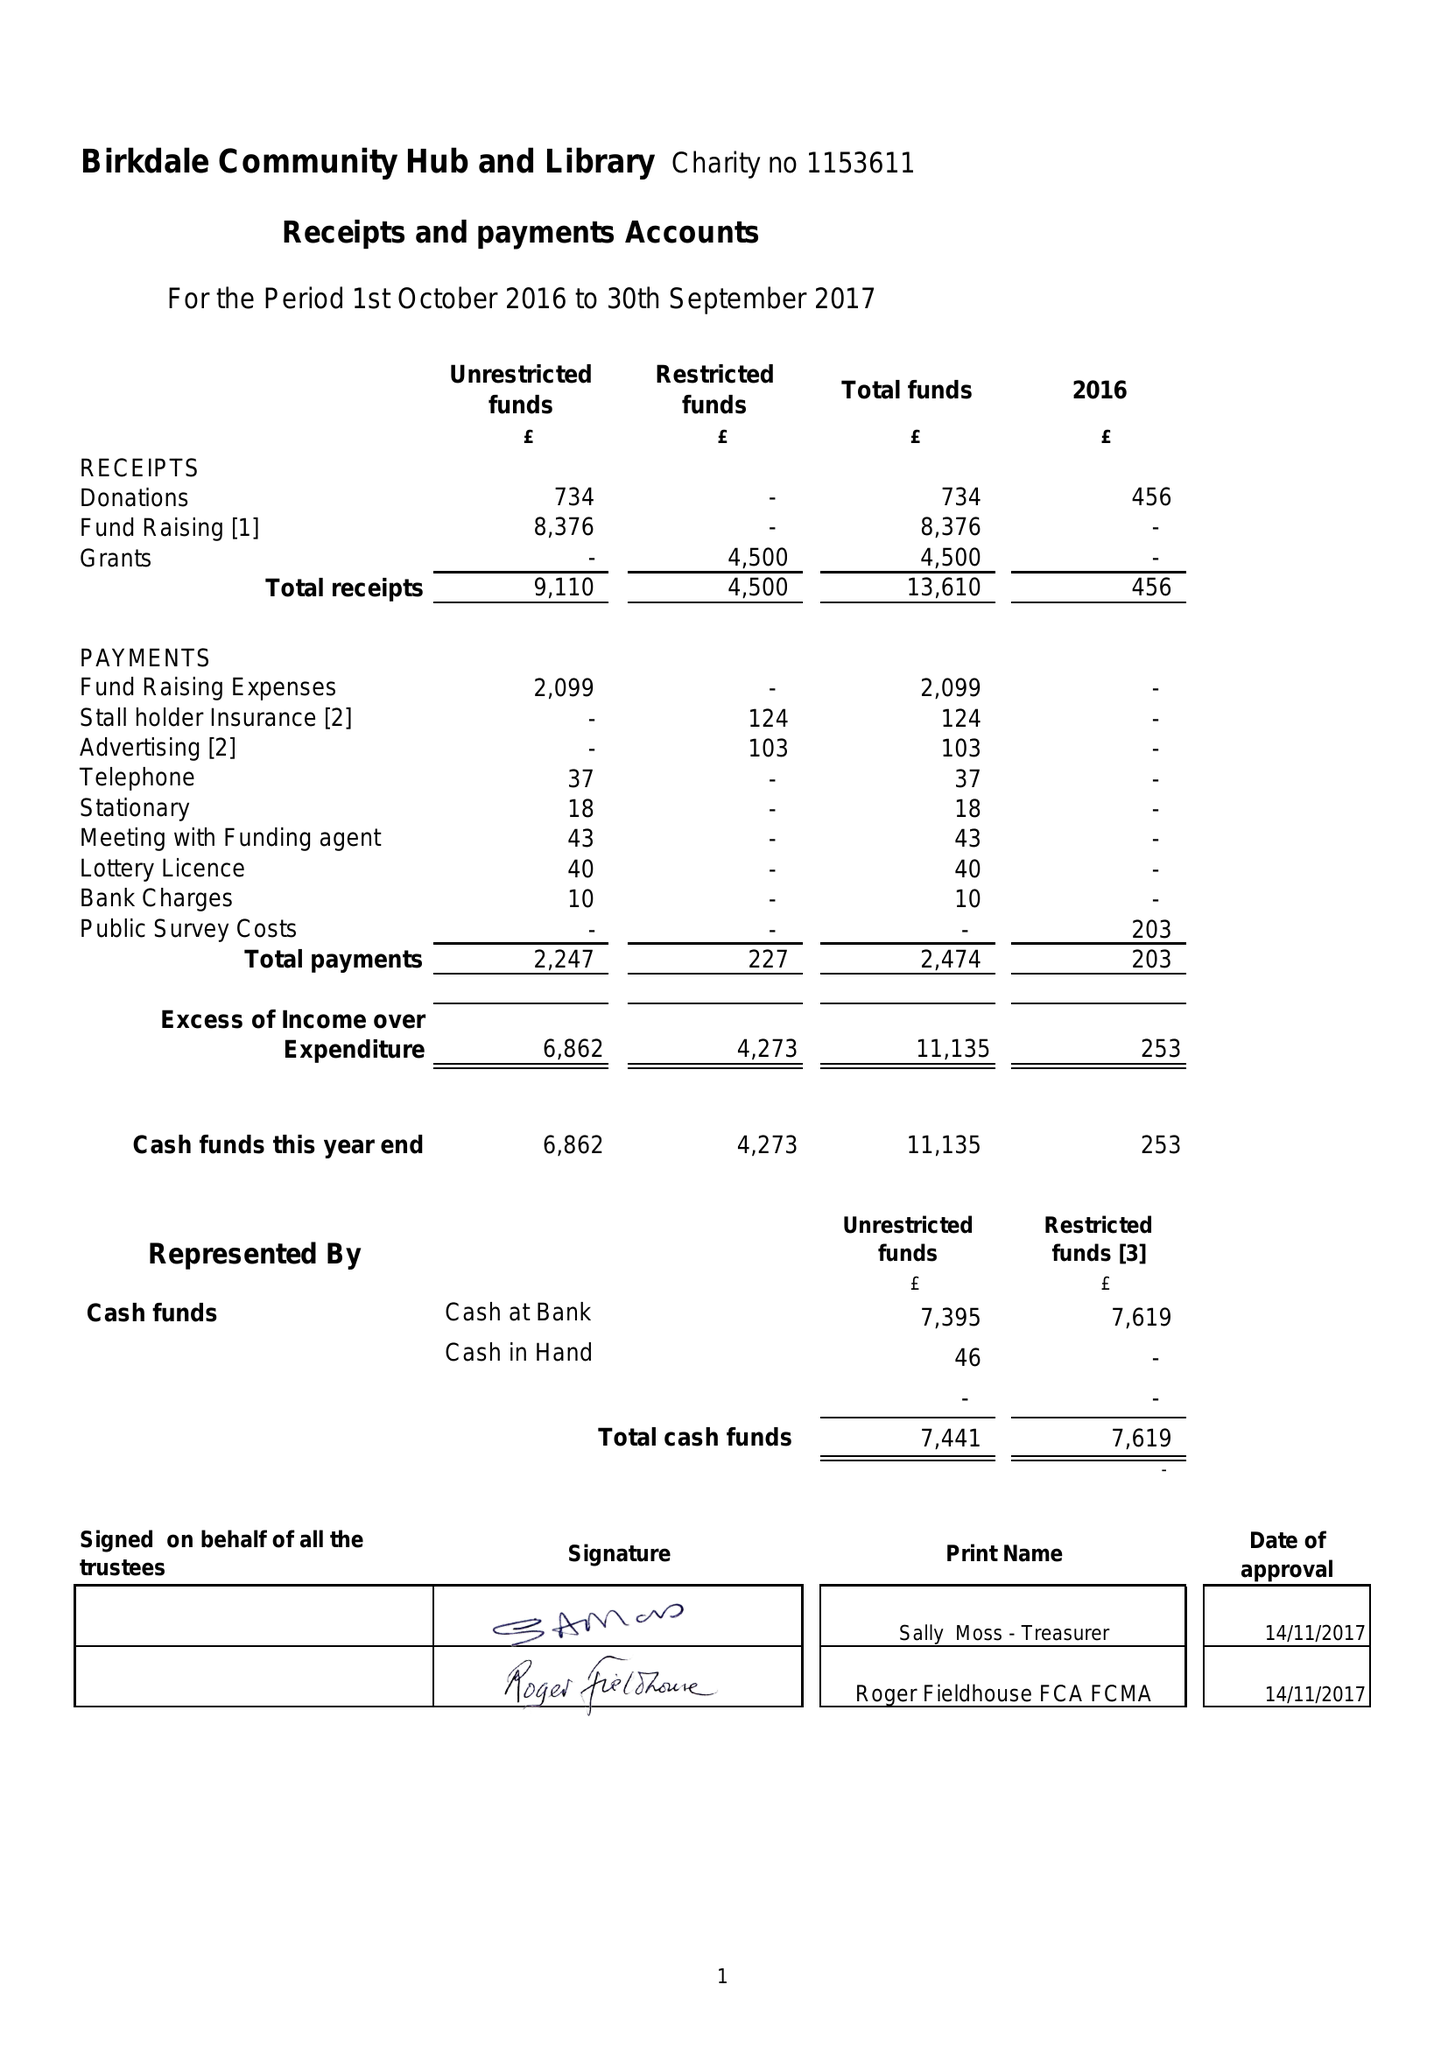What is the value for the charity_number?
Answer the question using a single word or phrase. 1153611 